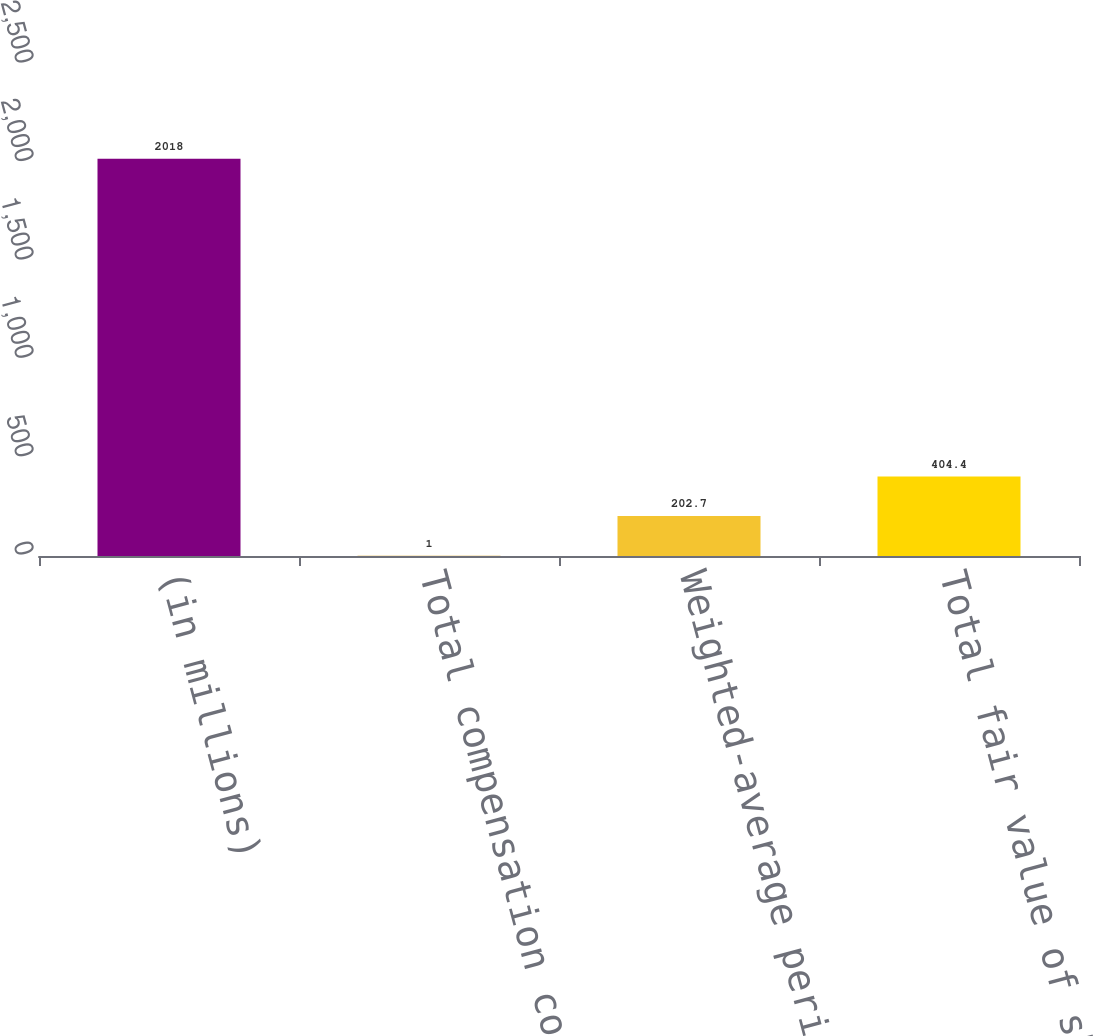Convert chart to OTSL. <chart><loc_0><loc_0><loc_500><loc_500><bar_chart><fcel>(in millions)<fcel>Total compensation cost net of<fcel>Weighted-average period over<fcel>Total fair value of shares<nl><fcel>2018<fcel>1<fcel>202.7<fcel>404.4<nl></chart> 